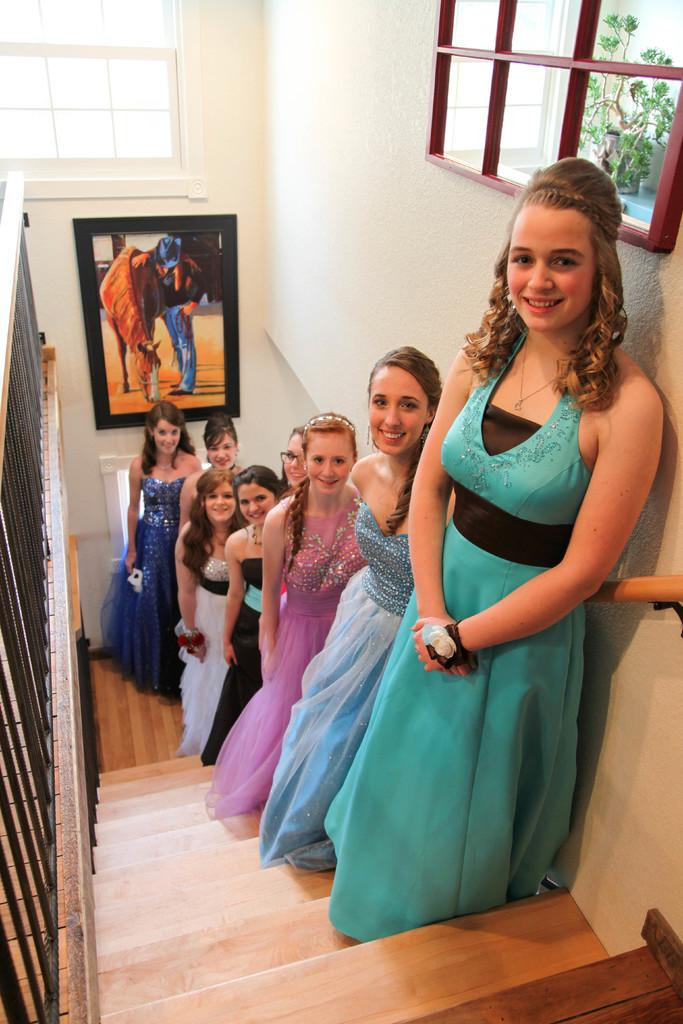What are the women in the image doing? The women are standing on the stairs. Can you describe any objects or decorations in the image? There is a photo frame visible in the image. What can be seen in the background of the image? There are windows and a wall in the background. Is there any vegetation present in the image? Yes, there is a plant beside a window. What type of sea creatures can be seen swimming in the image? There is no sea or sea creatures present in the image. Is there a prison visible in the image? No, there is no prison present in the image. 